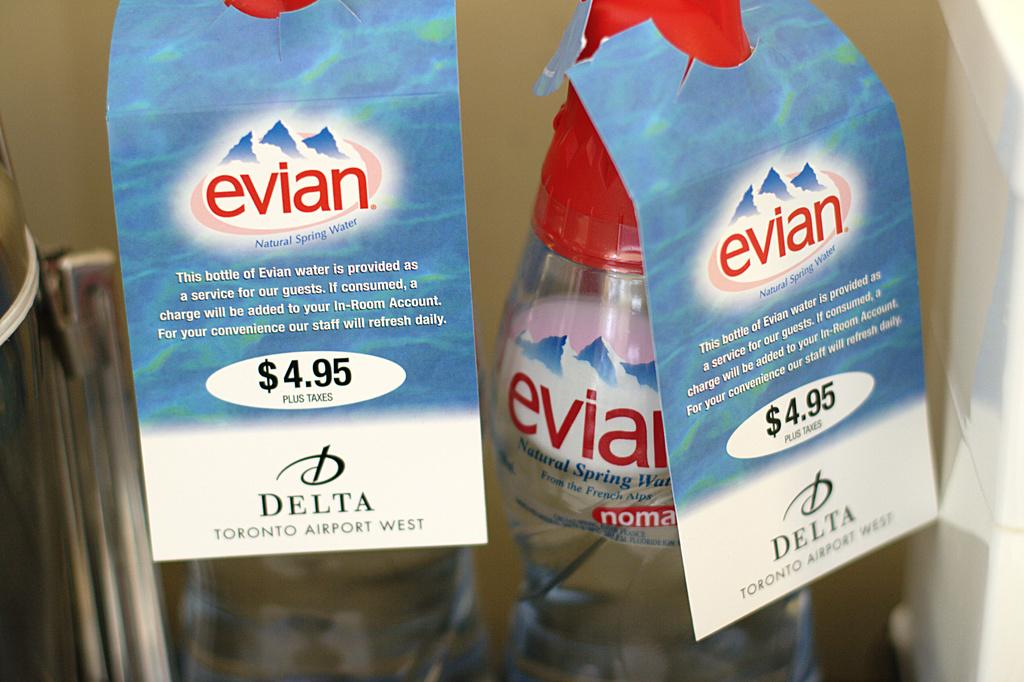Provide a one-sentence caption for the provided image. two bottles of evian water for sale at the delta toronto airport west. 